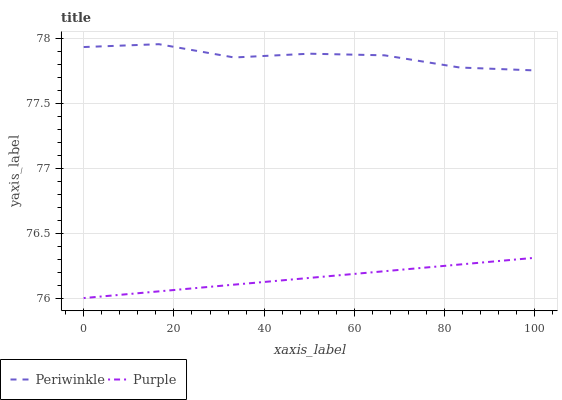Does Purple have the minimum area under the curve?
Answer yes or no. Yes. Does Periwinkle have the maximum area under the curve?
Answer yes or no. Yes. Does Periwinkle have the minimum area under the curve?
Answer yes or no. No. Is Purple the smoothest?
Answer yes or no. Yes. Is Periwinkle the roughest?
Answer yes or no. Yes. Is Periwinkle the smoothest?
Answer yes or no. No. Does Purple have the lowest value?
Answer yes or no. Yes. Does Periwinkle have the lowest value?
Answer yes or no. No. Does Periwinkle have the highest value?
Answer yes or no. Yes. Is Purple less than Periwinkle?
Answer yes or no. Yes. Is Periwinkle greater than Purple?
Answer yes or no. Yes. Does Purple intersect Periwinkle?
Answer yes or no. No. 